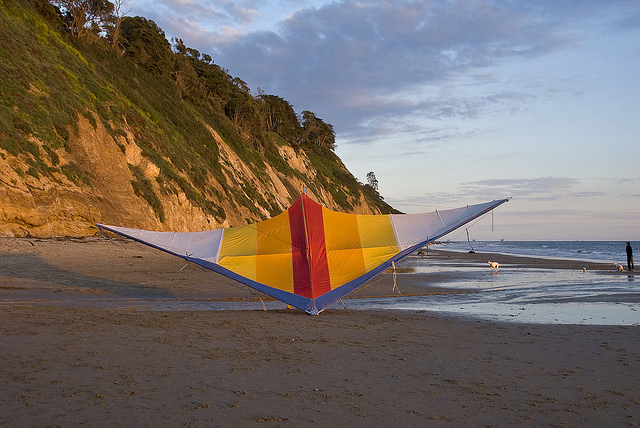Can you explain the key differences between a kite and a hang glider? Certainly! Both kites and hang gliders are aerodynamic objects that leverage wind for movement, but they serve distinct purposes and differ significantly in design and use:

1. Kites: These are generally lightweight, crafted from fabric or paper stretched over a frame, and are flown by being tethered to a string. They are controlled from the ground and are used primarily for recreational purposes. Kites come in various sizes and designs and are accessible to all age groups without the need for specialized training.

2. Hang Gliders: These are non-motorized aircraft designed for human flight. Made with a rigid frame and fabric that forms a wing, hang gliders are controlled by a pilot who is suspended from the frame using a harness. Steering is achieved by shifting body weight, making hang gliding an air sport that necessitates proper training and adherence to safety guidelines.

Key differences include:
- **Purpose**: Kites are for recreational fun, while hang gliders enable human flight and are considered a sport.
- **Structure**: Kites are lightweight and simpler in construction, whereas hang gliders have a robust wing structure designed to generate lift.
- **Control**: Kites are managed from the ground, while hang gliders are piloted by individuals in flight.
- **Experience**: Kite flying is easy and safe for all, while hang gliding requires significant training and certification.

In the image, the main object is a colorful kite resting on a beach, not a hang glider. 